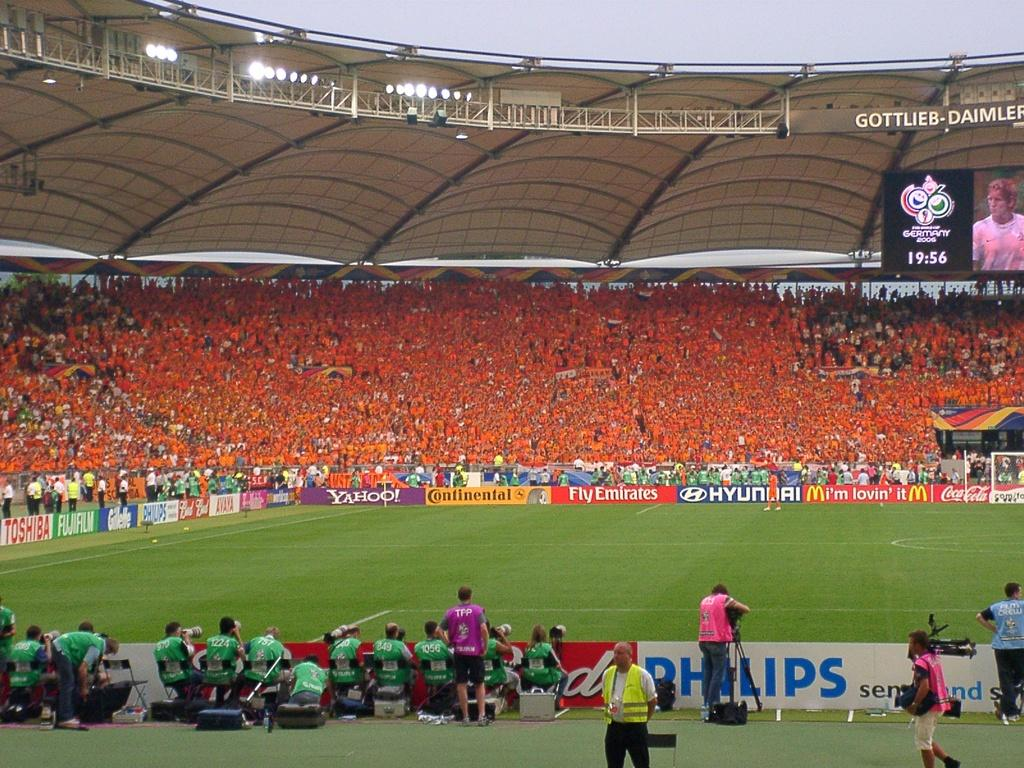<image>
Give a short and clear explanation of the subsequent image. a soccer stadium with many fans, and advertisements surrounding the pitch, such as hyundai and fly emirates 